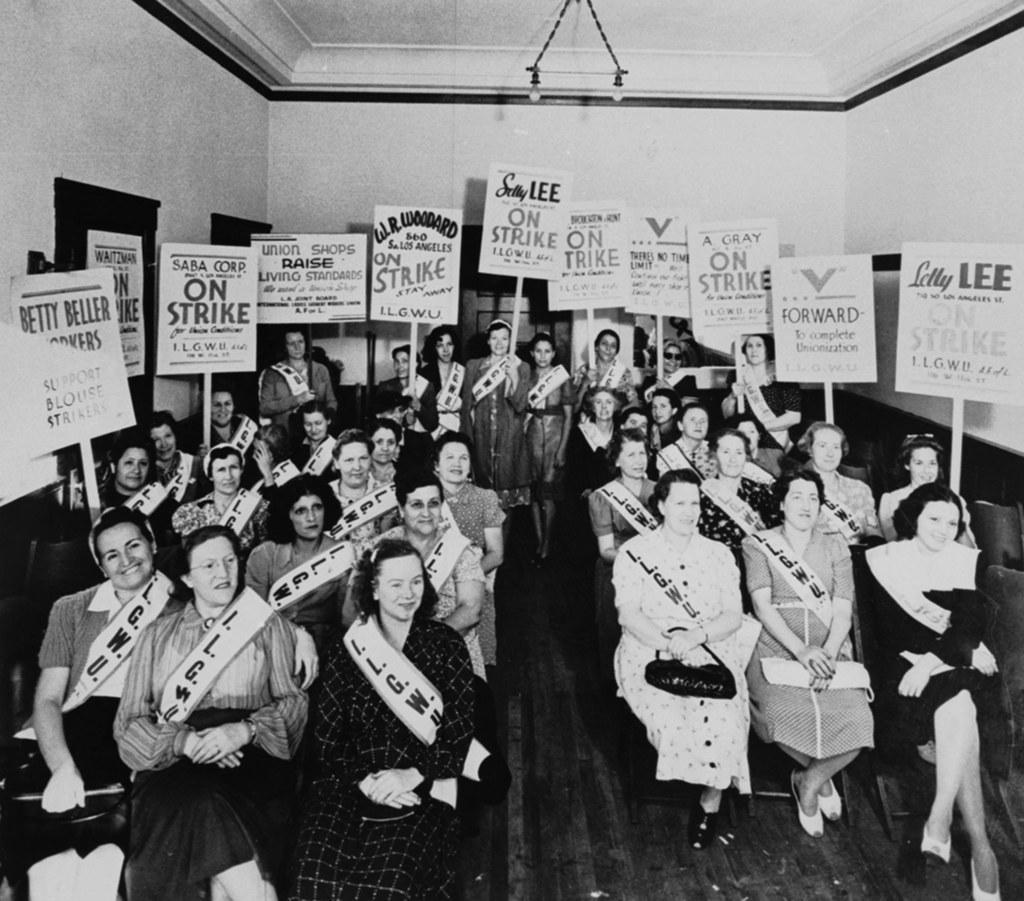In one or two sentences, can you explain what this image depicts? In this picture we can see a group of person sitting on the chair. Here we can see women who are holding the posters. On the top there is a chandelier. On the bottom we can see the wooden floor. 